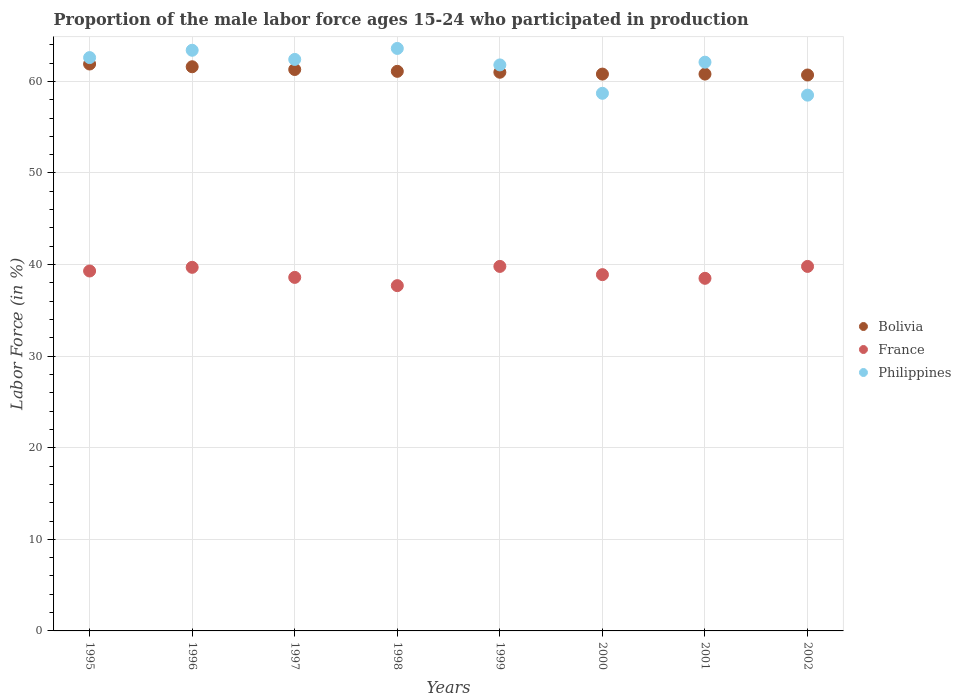How many different coloured dotlines are there?
Provide a short and direct response. 3. What is the proportion of the male labor force who participated in production in Philippines in 2001?
Your response must be concise. 62.1. Across all years, what is the maximum proportion of the male labor force who participated in production in Philippines?
Provide a succinct answer. 63.6. Across all years, what is the minimum proportion of the male labor force who participated in production in France?
Your answer should be very brief. 37.7. What is the total proportion of the male labor force who participated in production in Philippines in the graph?
Keep it short and to the point. 493.1. What is the difference between the proportion of the male labor force who participated in production in Bolivia in 1996 and that in 1997?
Your answer should be very brief. 0.3. What is the difference between the proportion of the male labor force who participated in production in Bolivia in 1995 and the proportion of the male labor force who participated in production in France in 1997?
Make the answer very short. 23.3. What is the average proportion of the male labor force who participated in production in France per year?
Keep it short and to the point. 39.04. In the year 1999, what is the difference between the proportion of the male labor force who participated in production in France and proportion of the male labor force who participated in production in Bolivia?
Offer a terse response. -21.2. In how many years, is the proportion of the male labor force who participated in production in Bolivia greater than 28 %?
Offer a very short reply. 8. What is the ratio of the proportion of the male labor force who participated in production in Bolivia in 1995 to that in 1996?
Your answer should be compact. 1. Is the proportion of the male labor force who participated in production in France in 1995 less than that in 1997?
Your answer should be compact. No. Is the difference between the proportion of the male labor force who participated in production in France in 1999 and 2002 greater than the difference between the proportion of the male labor force who participated in production in Bolivia in 1999 and 2002?
Make the answer very short. No. What is the difference between the highest and the lowest proportion of the male labor force who participated in production in Philippines?
Give a very brief answer. 5.1. Does the proportion of the male labor force who participated in production in Bolivia monotonically increase over the years?
Your answer should be compact. No. Is the proportion of the male labor force who participated in production in Bolivia strictly less than the proportion of the male labor force who participated in production in France over the years?
Offer a terse response. No. How many dotlines are there?
Provide a short and direct response. 3. What is the difference between two consecutive major ticks on the Y-axis?
Ensure brevity in your answer.  10. Are the values on the major ticks of Y-axis written in scientific E-notation?
Give a very brief answer. No. Does the graph contain any zero values?
Ensure brevity in your answer.  No. How many legend labels are there?
Your answer should be compact. 3. How are the legend labels stacked?
Offer a very short reply. Vertical. What is the title of the graph?
Your answer should be very brief. Proportion of the male labor force ages 15-24 who participated in production. Does "Cuba" appear as one of the legend labels in the graph?
Offer a very short reply. No. What is the label or title of the Y-axis?
Your answer should be very brief. Labor Force (in %). What is the Labor Force (in %) of Bolivia in 1995?
Your response must be concise. 61.9. What is the Labor Force (in %) of France in 1995?
Offer a terse response. 39.3. What is the Labor Force (in %) in Philippines in 1995?
Offer a terse response. 62.6. What is the Labor Force (in %) in Bolivia in 1996?
Provide a short and direct response. 61.6. What is the Labor Force (in %) of France in 1996?
Your answer should be compact. 39.7. What is the Labor Force (in %) of Philippines in 1996?
Provide a succinct answer. 63.4. What is the Labor Force (in %) in Bolivia in 1997?
Your answer should be compact. 61.3. What is the Labor Force (in %) of France in 1997?
Ensure brevity in your answer.  38.6. What is the Labor Force (in %) of Philippines in 1997?
Make the answer very short. 62.4. What is the Labor Force (in %) in Bolivia in 1998?
Provide a succinct answer. 61.1. What is the Labor Force (in %) of France in 1998?
Keep it short and to the point. 37.7. What is the Labor Force (in %) in Philippines in 1998?
Your answer should be very brief. 63.6. What is the Labor Force (in %) of Bolivia in 1999?
Your answer should be compact. 61. What is the Labor Force (in %) in France in 1999?
Provide a short and direct response. 39.8. What is the Labor Force (in %) in Philippines in 1999?
Offer a very short reply. 61.8. What is the Labor Force (in %) of Bolivia in 2000?
Your answer should be compact. 60.8. What is the Labor Force (in %) of France in 2000?
Your response must be concise. 38.9. What is the Labor Force (in %) in Philippines in 2000?
Your response must be concise. 58.7. What is the Labor Force (in %) of Bolivia in 2001?
Give a very brief answer. 60.8. What is the Labor Force (in %) in France in 2001?
Offer a very short reply. 38.5. What is the Labor Force (in %) in Philippines in 2001?
Your answer should be compact. 62.1. What is the Labor Force (in %) in Bolivia in 2002?
Your answer should be compact. 60.7. What is the Labor Force (in %) in France in 2002?
Your answer should be compact. 39.8. What is the Labor Force (in %) of Philippines in 2002?
Provide a short and direct response. 58.5. Across all years, what is the maximum Labor Force (in %) of Bolivia?
Ensure brevity in your answer.  61.9. Across all years, what is the maximum Labor Force (in %) of France?
Ensure brevity in your answer.  39.8. Across all years, what is the maximum Labor Force (in %) of Philippines?
Your answer should be very brief. 63.6. Across all years, what is the minimum Labor Force (in %) of Bolivia?
Your response must be concise. 60.7. Across all years, what is the minimum Labor Force (in %) in France?
Offer a terse response. 37.7. Across all years, what is the minimum Labor Force (in %) in Philippines?
Provide a succinct answer. 58.5. What is the total Labor Force (in %) of Bolivia in the graph?
Your response must be concise. 489.2. What is the total Labor Force (in %) of France in the graph?
Keep it short and to the point. 312.3. What is the total Labor Force (in %) of Philippines in the graph?
Your answer should be very brief. 493.1. What is the difference between the Labor Force (in %) of Bolivia in 1995 and that in 1996?
Offer a terse response. 0.3. What is the difference between the Labor Force (in %) in Bolivia in 1995 and that in 1997?
Make the answer very short. 0.6. What is the difference between the Labor Force (in %) in Philippines in 1995 and that in 1997?
Make the answer very short. 0.2. What is the difference between the Labor Force (in %) of Bolivia in 1995 and that in 1998?
Ensure brevity in your answer.  0.8. What is the difference between the Labor Force (in %) of France in 1995 and that in 1998?
Keep it short and to the point. 1.6. What is the difference between the Labor Force (in %) in Philippines in 1995 and that in 1999?
Keep it short and to the point. 0.8. What is the difference between the Labor Force (in %) in France in 1995 and that in 2000?
Ensure brevity in your answer.  0.4. What is the difference between the Labor Force (in %) in Philippines in 1995 and that in 2000?
Make the answer very short. 3.9. What is the difference between the Labor Force (in %) in Philippines in 1995 and that in 2002?
Offer a very short reply. 4.1. What is the difference between the Labor Force (in %) in Bolivia in 1996 and that in 1997?
Ensure brevity in your answer.  0.3. What is the difference between the Labor Force (in %) of France in 1996 and that in 1997?
Ensure brevity in your answer.  1.1. What is the difference between the Labor Force (in %) of Philippines in 1996 and that in 1998?
Give a very brief answer. -0.2. What is the difference between the Labor Force (in %) of Bolivia in 1996 and that in 1999?
Ensure brevity in your answer.  0.6. What is the difference between the Labor Force (in %) in Philippines in 1996 and that in 1999?
Provide a succinct answer. 1.6. What is the difference between the Labor Force (in %) of Philippines in 1996 and that in 2002?
Ensure brevity in your answer.  4.9. What is the difference between the Labor Force (in %) in France in 1997 and that in 1998?
Provide a short and direct response. 0.9. What is the difference between the Labor Force (in %) in Philippines in 1997 and that in 1998?
Offer a very short reply. -1.2. What is the difference between the Labor Force (in %) in Bolivia in 1997 and that in 1999?
Your answer should be compact. 0.3. What is the difference between the Labor Force (in %) of Philippines in 1997 and that in 1999?
Ensure brevity in your answer.  0.6. What is the difference between the Labor Force (in %) of Philippines in 1997 and that in 2000?
Provide a succinct answer. 3.7. What is the difference between the Labor Force (in %) in Bolivia in 1997 and that in 2001?
Provide a short and direct response. 0.5. What is the difference between the Labor Force (in %) in France in 1997 and that in 2001?
Provide a short and direct response. 0.1. What is the difference between the Labor Force (in %) of Philippines in 1997 and that in 2001?
Offer a very short reply. 0.3. What is the difference between the Labor Force (in %) in Bolivia in 1997 and that in 2002?
Your answer should be very brief. 0.6. What is the difference between the Labor Force (in %) of Philippines in 1997 and that in 2002?
Keep it short and to the point. 3.9. What is the difference between the Labor Force (in %) in Bolivia in 1998 and that in 1999?
Offer a very short reply. 0.1. What is the difference between the Labor Force (in %) of Philippines in 1998 and that in 2000?
Offer a very short reply. 4.9. What is the difference between the Labor Force (in %) in France in 1998 and that in 2001?
Offer a very short reply. -0.8. What is the difference between the Labor Force (in %) in France in 1998 and that in 2002?
Keep it short and to the point. -2.1. What is the difference between the Labor Force (in %) in Bolivia in 1999 and that in 2000?
Offer a very short reply. 0.2. What is the difference between the Labor Force (in %) of France in 1999 and that in 2000?
Your answer should be very brief. 0.9. What is the difference between the Labor Force (in %) in Philippines in 1999 and that in 2000?
Give a very brief answer. 3.1. What is the difference between the Labor Force (in %) of Bolivia in 1999 and that in 2001?
Your response must be concise. 0.2. What is the difference between the Labor Force (in %) in Philippines in 1999 and that in 2001?
Your answer should be compact. -0.3. What is the difference between the Labor Force (in %) in Bolivia in 1999 and that in 2002?
Provide a succinct answer. 0.3. What is the difference between the Labor Force (in %) of France in 2000 and that in 2002?
Keep it short and to the point. -0.9. What is the difference between the Labor Force (in %) in Philippines in 2000 and that in 2002?
Offer a terse response. 0.2. What is the difference between the Labor Force (in %) in Bolivia in 2001 and that in 2002?
Give a very brief answer. 0.1. What is the difference between the Labor Force (in %) in Bolivia in 1995 and the Labor Force (in %) in France in 1996?
Provide a succinct answer. 22.2. What is the difference between the Labor Force (in %) of France in 1995 and the Labor Force (in %) of Philippines in 1996?
Provide a short and direct response. -24.1. What is the difference between the Labor Force (in %) of Bolivia in 1995 and the Labor Force (in %) of France in 1997?
Ensure brevity in your answer.  23.3. What is the difference between the Labor Force (in %) of France in 1995 and the Labor Force (in %) of Philippines in 1997?
Give a very brief answer. -23.1. What is the difference between the Labor Force (in %) of Bolivia in 1995 and the Labor Force (in %) of France in 1998?
Offer a terse response. 24.2. What is the difference between the Labor Force (in %) in Bolivia in 1995 and the Labor Force (in %) in Philippines in 1998?
Ensure brevity in your answer.  -1.7. What is the difference between the Labor Force (in %) in France in 1995 and the Labor Force (in %) in Philippines in 1998?
Give a very brief answer. -24.3. What is the difference between the Labor Force (in %) of Bolivia in 1995 and the Labor Force (in %) of France in 1999?
Provide a succinct answer. 22.1. What is the difference between the Labor Force (in %) of Bolivia in 1995 and the Labor Force (in %) of Philippines in 1999?
Your response must be concise. 0.1. What is the difference between the Labor Force (in %) of France in 1995 and the Labor Force (in %) of Philippines in 1999?
Provide a short and direct response. -22.5. What is the difference between the Labor Force (in %) of Bolivia in 1995 and the Labor Force (in %) of Philippines in 2000?
Offer a terse response. 3.2. What is the difference between the Labor Force (in %) in France in 1995 and the Labor Force (in %) in Philippines in 2000?
Ensure brevity in your answer.  -19.4. What is the difference between the Labor Force (in %) of Bolivia in 1995 and the Labor Force (in %) of France in 2001?
Ensure brevity in your answer.  23.4. What is the difference between the Labor Force (in %) in Bolivia in 1995 and the Labor Force (in %) in Philippines in 2001?
Offer a terse response. -0.2. What is the difference between the Labor Force (in %) in France in 1995 and the Labor Force (in %) in Philippines in 2001?
Offer a very short reply. -22.8. What is the difference between the Labor Force (in %) in Bolivia in 1995 and the Labor Force (in %) in France in 2002?
Offer a very short reply. 22.1. What is the difference between the Labor Force (in %) of Bolivia in 1995 and the Labor Force (in %) of Philippines in 2002?
Your answer should be very brief. 3.4. What is the difference between the Labor Force (in %) in France in 1995 and the Labor Force (in %) in Philippines in 2002?
Your response must be concise. -19.2. What is the difference between the Labor Force (in %) in Bolivia in 1996 and the Labor Force (in %) in Philippines in 1997?
Your answer should be very brief. -0.8. What is the difference between the Labor Force (in %) in France in 1996 and the Labor Force (in %) in Philippines in 1997?
Your response must be concise. -22.7. What is the difference between the Labor Force (in %) in Bolivia in 1996 and the Labor Force (in %) in France in 1998?
Your answer should be compact. 23.9. What is the difference between the Labor Force (in %) of France in 1996 and the Labor Force (in %) of Philippines in 1998?
Your response must be concise. -23.9. What is the difference between the Labor Force (in %) in Bolivia in 1996 and the Labor Force (in %) in France in 1999?
Offer a terse response. 21.8. What is the difference between the Labor Force (in %) of Bolivia in 1996 and the Labor Force (in %) of Philippines in 1999?
Your answer should be compact. -0.2. What is the difference between the Labor Force (in %) in France in 1996 and the Labor Force (in %) in Philippines in 1999?
Your answer should be compact. -22.1. What is the difference between the Labor Force (in %) in Bolivia in 1996 and the Labor Force (in %) in France in 2000?
Offer a very short reply. 22.7. What is the difference between the Labor Force (in %) of Bolivia in 1996 and the Labor Force (in %) of France in 2001?
Your answer should be very brief. 23.1. What is the difference between the Labor Force (in %) of France in 1996 and the Labor Force (in %) of Philippines in 2001?
Offer a very short reply. -22.4. What is the difference between the Labor Force (in %) of Bolivia in 1996 and the Labor Force (in %) of France in 2002?
Offer a very short reply. 21.8. What is the difference between the Labor Force (in %) in France in 1996 and the Labor Force (in %) in Philippines in 2002?
Give a very brief answer. -18.8. What is the difference between the Labor Force (in %) in Bolivia in 1997 and the Labor Force (in %) in France in 1998?
Offer a very short reply. 23.6. What is the difference between the Labor Force (in %) of Bolivia in 1997 and the Labor Force (in %) of Philippines in 1998?
Your response must be concise. -2.3. What is the difference between the Labor Force (in %) of France in 1997 and the Labor Force (in %) of Philippines in 1998?
Make the answer very short. -25. What is the difference between the Labor Force (in %) of Bolivia in 1997 and the Labor Force (in %) of France in 1999?
Provide a succinct answer. 21.5. What is the difference between the Labor Force (in %) in Bolivia in 1997 and the Labor Force (in %) in Philippines in 1999?
Make the answer very short. -0.5. What is the difference between the Labor Force (in %) of France in 1997 and the Labor Force (in %) of Philippines in 1999?
Provide a short and direct response. -23.2. What is the difference between the Labor Force (in %) in Bolivia in 1997 and the Labor Force (in %) in France in 2000?
Keep it short and to the point. 22.4. What is the difference between the Labor Force (in %) in Bolivia in 1997 and the Labor Force (in %) in Philippines in 2000?
Offer a terse response. 2.6. What is the difference between the Labor Force (in %) in France in 1997 and the Labor Force (in %) in Philippines in 2000?
Offer a terse response. -20.1. What is the difference between the Labor Force (in %) of Bolivia in 1997 and the Labor Force (in %) of France in 2001?
Your answer should be compact. 22.8. What is the difference between the Labor Force (in %) of France in 1997 and the Labor Force (in %) of Philippines in 2001?
Offer a terse response. -23.5. What is the difference between the Labor Force (in %) of Bolivia in 1997 and the Labor Force (in %) of France in 2002?
Provide a short and direct response. 21.5. What is the difference between the Labor Force (in %) of France in 1997 and the Labor Force (in %) of Philippines in 2002?
Make the answer very short. -19.9. What is the difference between the Labor Force (in %) of Bolivia in 1998 and the Labor Force (in %) of France in 1999?
Give a very brief answer. 21.3. What is the difference between the Labor Force (in %) in Bolivia in 1998 and the Labor Force (in %) in Philippines in 1999?
Offer a terse response. -0.7. What is the difference between the Labor Force (in %) of France in 1998 and the Labor Force (in %) of Philippines in 1999?
Your response must be concise. -24.1. What is the difference between the Labor Force (in %) of Bolivia in 1998 and the Labor Force (in %) of Philippines in 2000?
Offer a very short reply. 2.4. What is the difference between the Labor Force (in %) in Bolivia in 1998 and the Labor Force (in %) in France in 2001?
Your answer should be compact. 22.6. What is the difference between the Labor Force (in %) in Bolivia in 1998 and the Labor Force (in %) in Philippines in 2001?
Your response must be concise. -1. What is the difference between the Labor Force (in %) in France in 1998 and the Labor Force (in %) in Philippines in 2001?
Make the answer very short. -24.4. What is the difference between the Labor Force (in %) of Bolivia in 1998 and the Labor Force (in %) of France in 2002?
Provide a succinct answer. 21.3. What is the difference between the Labor Force (in %) of France in 1998 and the Labor Force (in %) of Philippines in 2002?
Provide a succinct answer. -20.8. What is the difference between the Labor Force (in %) of Bolivia in 1999 and the Labor Force (in %) of France in 2000?
Your answer should be very brief. 22.1. What is the difference between the Labor Force (in %) of France in 1999 and the Labor Force (in %) of Philippines in 2000?
Provide a short and direct response. -18.9. What is the difference between the Labor Force (in %) in Bolivia in 1999 and the Labor Force (in %) in France in 2001?
Make the answer very short. 22.5. What is the difference between the Labor Force (in %) in Bolivia in 1999 and the Labor Force (in %) in Philippines in 2001?
Give a very brief answer. -1.1. What is the difference between the Labor Force (in %) in France in 1999 and the Labor Force (in %) in Philippines in 2001?
Keep it short and to the point. -22.3. What is the difference between the Labor Force (in %) of Bolivia in 1999 and the Labor Force (in %) of France in 2002?
Ensure brevity in your answer.  21.2. What is the difference between the Labor Force (in %) in Bolivia in 1999 and the Labor Force (in %) in Philippines in 2002?
Provide a short and direct response. 2.5. What is the difference between the Labor Force (in %) of France in 1999 and the Labor Force (in %) of Philippines in 2002?
Keep it short and to the point. -18.7. What is the difference between the Labor Force (in %) of Bolivia in 2000 and the Labor Force (in %) of France in 2001?
Offer a terse response. 22.3. What is the difference between the Labor Force (in %) of Bolivia in 2000 and the Labor Force (in %) of Philippines in 2001?
Your answer should be very brief. -1.3. What is the difference between the Labor Force (in %) of France in 2000 and the Labor Force (in %) of Philippines in 2001?
Make the answer very short. -23.2. What is the difference between the Labor Force (in %) in Bolivia in 2000 and the Labor Force (in %) in Philippines in 2002?
Your response must be concise. 2.3. What is the difference between the Labor Force (in %) in France in 2000 and the Labor Force (in %) in Philippines in 2002?
Provide a succinct answer. -19.6. What is the difference between the Labor Force (in %) of Bolivia in 2001 and the Labor Force (in %) of Philippines in 2002?
Provide a short and direct response. 2.3. What is the difference between the Labor Force (in %) in France in 2001 and the Labor Force (in %) in Philippines in 2002?
Offer a terse response. -20. What is the average Labor Force (in %) in Bolivia per year?
Your response must be concise. 61.15. What is the average Labor Force (in %) in France per year?
Keep it short and to the point. 39.04. What is the average Labor Force (in %) of Philippines per year?
Your answer should be compact. 61.64. In the year 1995, what is the difference between the Labor Force (in %) of Bolivia and Labor Force (in %) of France?
Give a very brief answer. 22.6. In the year 1995, what is the difference between the Labor Force (in %) in France and Labor Force (in %) in Philippines?
Offer a terse response. -23.3. In the year 1996, what is the difference between the Labor Force (in %) in Bolivia and Labor Force (in %) in France?
Give a very brief answer. 21.9. In the year 1996, what is the difference between the Labor Force (in %) in France and Labor Force (in %) in Philippines?
Make the answer very short. -23.7. In the year 1997, what is the difference between the Labor Force (in %) of Bolivia and Labor Force (in %) of France?
Offer a terse response. 22.7. In the year 1997, what is the difference between the Labor Force (in %) in France and Labor Force (in %) in Philippines?
Your answer should be very brief. -23.8. In the year 1998, what is the difference between the Labor Force (in %) of Bolivia and Labor Force (in %) of France?
Keep it short and to the point. 23.4. In the year 1998, what is the difference between the Labor Force (in %) in Bolivia and Labor Force (in %) in Philippines?
Your answer should be compact. -2.5. In the year 1998, what is the difference between the Labor Force (in %) in France and Labor Force (in %) in Philippines?
Ensure brevity in your answer.  -25.9. In the year 1999, what is the difference between the Labor Force (in %) of Bolivia and Labor Force (in %) of France?
Give a very brief answer. 21.2. In the year 1999, what is the difference between the Labor Force (in %) of Bolivia and Labor Force (in %) of Philippines?
Keep it short and to the point. -0.8. In the year 1999, what is the difference between the Labor Force (in %) of France and Labor Force (in %) of Philippines?
Ensure brevity in your answer.  -22. In the year 2000, what is the difference between the Labor Force (in %) of Bolivia and Labor Force (in %) of France?
Your answer should be very brief. 21.9. In the year 2000, what is the difference between the Labor Force (in %) of France and Labor Force (in %) of Philippines?
Your answer should be compact. -19.8. In the year 2001, what is the difference between the Labor Force (in %) of Bolivia and Labor Force (in %) of France?
Your response must be concise. 22.3. In the year 2001, what is the difference between the Labor Force (in %) of Bolivia and Labor Force (in %) of Philippines?
Offer a terse response. -1.3. In the year 2001, what is the difference between the Labor Force (in %) of France and Labor Force (in %) of Philippines?
Offer a very short reply. -23.6. In the year 2002, what is the difference between the Labor Force (in %) of Bolivia and Labor Force (in %) of France?
Your answer should be compact. 20.9. In the year 2002, what is the difference between the Labor Force (in %) in France and Labor Force (in %) in Philippines?
Your response must be concise. -18.7. What is the ratio of the Labor Force (in %) of France in 1995 to that in 1996?
Make the answer very short. 0.99. What is the ratio of the Labor Force (in %) of Philippines in 1995 to that in 1996?
Give a very brief answer. 0.99. What is the ratio of the Labor Force (in %) of Bolivia in 1995 to that in 1997?
Your response must be concise. 1.01. What is the ratio of the Labor Force (in %) of France in 1995 to that in 1997?
Keep it short and to the point. 1.02. What is the ratio of the Labor Force (in %) in Bolivia in 1995 to that in 1998?
Ensure brevity in your answer.  1.01. What is the ratio of the Labor Force (in %) in France in 1995 to that in 1998?
Provide a succinct answer. 1.04. What is the ratio of the Labor Force (in %) of Philippines in 1995 to that in 1998?
Offer a very short reply. 0.98. What is the ratio of the Labor Force (in %) in Bolivia in 1995 to that in 1999?
Give a very brief answer. 1.01. What is the ratio of the Labor Force (in %) of France in 1995 to that in 1999?
Ensure brevity in your answer.  0.99. What is the ratio of the Labor Force (in %) in Philippines in 1995 to that in 1999?
Ensure brevity in your answer.  1.01. What is the ratio of the Labor Force (in %) of Bolivia in 1995 to that in 2000?
Offer a very short reply. 1.02. What is the ratio of the Labor Force (in %) in France in 1995 to that in 2000?
Your response must be concise. 1.01. What is the ratio of the Labor Force (in %) of Philippines in 1995 to that in 2000?
Offer a very short reply. 1.07. What is the ratio of the Labor Force (in %) of Bolivia in 1995 to that in 2001?
Keep it short and to the point. 1.02. What is the ratio of the Labor Force (in %) of France in 1995 to that in 2001?
Keep it short and to the point. 1.02. What is the ratio of the Labor Force (in %) in Philippines in 1995 to that in 2001?
Make the answer very short. 1.01. What is the ratio of the Labor Force (in %) in Bolivia in 1995 to that in 2002?
Ensure brevity in your answer.  1.02. What is the ratio of the Labor Force (in %) in France in 1995 to that in 2002?
Provide a succinct answer. 0.99. What is the ratio of the Labor Force (in %) of Philippines in 1995 to that in 2002?
Provide a short and direct response. 1.07. What is the ratio of the Labor Force (in %) in France in 1996 to that in 1997?
Your answer should be very brief. 1.03. What is the ratio of the Labor Force (in %) of Bolivia in 1996 to that in 1998?
Your response must be concise. 1.01. What is the ratio of the Labor Force (in %) in France in 1996 to that in 1998?
Provide a succinct answer. 1.05. What is the ratio of the Labor Force (in %) of Philippines in 1996 to that in 1998?
Keep it short and to the point. 1. What is the ratio of the Labor Force (in %) in Bolivia in 1996 to that in 1999?
Your answer should be very brief. 1.01. What is the ratio of the Labor Force (in %) in Philippines in 1996 to that in 1999?
Keep it short and to the point. 1.03. What is the ratio of the Labor Force (in %) of Bolivia in 1996 to that in 2000?
Provide a short and direct response. 1.01. What is the ratio of the Labor Force (in %) in France in 1996 to that in 2000?
Provide a succinct answer. 1.02. What is the ratio of the Labor Force (in %) in Philippines in 1996 to that in 2000?
Make the answer very short. 1.08. What is the ratio of the Labor Force (in %) in Bolivia in 1996 to that in 2001?
Give a very brief answer. 1.01. What is the ratio of the Labor Force (in %) in France in 1996 to that in 2001?
Your answer should be very brief. 1.03. What is the ratio of the Labor Force (in %) of Philippines in 1996 to that in 2001?
Offer a very short reply. 1.02. What is the ratio of the Labor Force (in %) of Bolivia in 1996 to that in 2002?
Your answer should be compact. 1.01. What is the ratio of the Labor Force (in %) in France in 1996 to that in 2002?
Make the answer very short. 1. What is the ratio of the Labor Force (in %) of Philippines in 1996 to that in 2002?
Your answer should be very brief. 1.08. What is the ratio of the Labor Force (in %) in France in 1997 to that in 1998?
Provide a succinct answer. 1.02. What is the ratio of the Labor Force (in %) in Philippines in 1997 to that in 1998?
Your answer should be very brief. 0.98. What is the ratio of the Labor Force (in %) of France in 1997 to that in 1999?
Your answer should be very brief. 0.97. What is the ratio of the Labor Force (in %) of Philippines in 1997 to that in 1999?
Provide a short and direct response. 1.01. What is the ratio of the Labor Force (in %) of Bolivia in 1997 to that in 2000?
Your answer should be very brief. 1.01. What is the ratio of the Labor Force (in %) in France in 1997 to that in 2000?
Keep it short and to the point. 0.99. What is the ratio of the Labor Force (in %) of Philippines in 1997 to that in 2000?
Provide a short and direct response. 1.06. What is the ratio of the Labor Force (in %) of Bolivia in 1997 to that in 2001?
Your answer should be very brief. 1.01. What is the ratio of the Labor Force (in %) of Philippines in 1997 to that in 2001?
Give a very brief answer. 1. What is the ratio of the Labor Force (in %) of Bolivia in 1997 to that in 2002?
Provide a short and direct response. 1.01. What is the ratio of the Labor Force (in %) in France in 1997 to that in 2002?
Offer a very short reply. 0.97. What is the ratio of the Labor Force (in %) in Philippines in 1997 to that in 2002?
Ensure brevity in your answer.  1.07. What is the ratio of the Labor Force (in %) of France in 1998 to that in 1999?
Ensure brevity in your answer.  0.95. What is the ratio of the Labor Force (in %) of Philippines in 1998 to that in 1999?
Ensure brevity in your answer.  1.03. What is the ratio of the Labor Force (in %) of Bolivia in 1998 to that in 2000?
Provide a short and direct response. 1. What is the ratio of the Labor Force (in %) in France in 1998 to that in 2000?
Provide a succinct answer. 0.97. What is the ratio of the Labor Force (in %) in Philippines in 1998 to that in 2000?
Offer a terse response. 1.08. What is the ratio of the Labor Force (in %) of France in 1998 to that in 2001?
Your answer should be compact. 0.98. What is the ratio of the Labor Force (in %) in Philippines in 1998 to that in 2001?
Make the answer very short. 1.02. What is the ratio of the Labor Force (in %) of Bolivia in 1998 to that in 2002?
Make the answer very short. 1.01. What is the ratio of the Labor Force (in %) of France in 1998 to that in 2002?
Your answer should be compact. 0.95. What is the ratio of the Labor Force (in %) in Philippines in 1998 to that in 2002?
Keep it short and to the point. 1.09. What is the ratio of the Labor Force (in %) in France in 1999 to that in 2000?
Offer a very short reply. 1.02. What is the ratio of the Labor Force (in %) of Philippines in 1999 to that in 2000?
Your answer should be very brief. 1.05. What is the ratio of the Labor Force (in %) of Bolivia in 1999 to that in 2001?
Your response must be concise. 1. What is the ratio of the Labor Force (in %) in France in 1999 to that in 2001?
Offer a very short reply. 1.03. What is the ratio of the Labor Force (in %) of Philippines in 1999 to that in 2001?
Your answer should be compact. 1. What is the ratio of the Labor Force (in %) in Bolivia in 1999 to that in 2002?
Ensure brevity in your answer.  1. What is the ratio of the Labor Force (in %) in France in 1999 to that in 2002?
Provide a short and direct response. 1. What is the ratio of the Labor Force (in %) of Philippines in 1999 to that in 2002?
Give a very brief answer. 1.06. What is the ratio of the Labor Force (in %) of France in 2000 to that in 2001?
Your answer should be compact. 1.01. What is the ratio of the Labor Force (in %) of Philippines in 2000 to that in 2001?
Make the answer very short. 0.95. What is the ratio of the Labor Force (in %) in Bolivia in 2000 to that in 2002?
Your answer should be very brief. 1. What is the ratio of the Labor Force (in %) of France in 2000 to that in 2002?
Your answer should be very brief. 0.98. What is the ratio of the Labor Force (in %) in Philippines in 2000 to that in 2002?
Provide a succinct answer. 1. What is the ratio of the Labor Force (in %) in France in 2001 to that in 2002?
Keep it short and to the point. 0.97. What is the ratio of the Labor Force (in %) in Philippines in 2001 to that in 2002?
Your response must be concise. 1.06. What is the difference between the highest and the second highest Labor Force (in %) in Bolivia?
Your answer should be compact. 0.3. What is the difference between the highest and the second highest Labor Force (in %) of France?
Offer a very short reply. 0. What is the difference between the highest and the lowest Labor Force (in %) in Bolivia?
Provide a succinct answer. 1.2. 